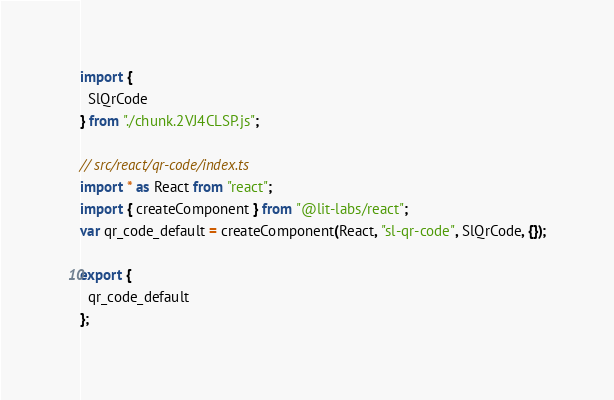<code> <loc_0><loc_0><loc_500><loc_500><_JavaScript_>import {
  SlQrCode
} from "./chunk.2VJ4CLSP.js";

// src/react/qr-code/index.ts
import * as React from "react";
import { createComponent } from "@lit-labs/react";
var qr_code_default = createComponent(React, "sl-qr-code", SlQrCode, {});

export {
  qr_code_default
};
</code> 